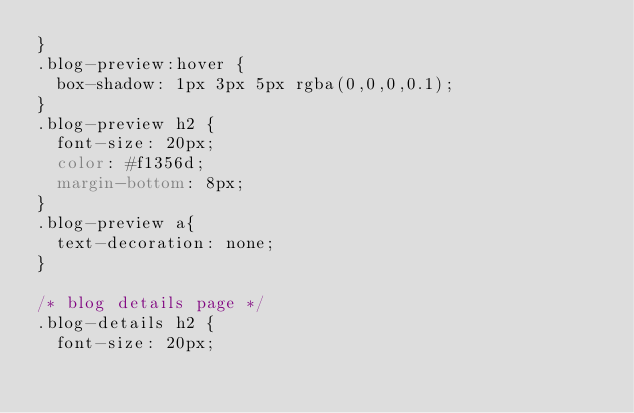<code> <loc_0><loc_0><loc_500><loc_500><_CSS_>}
.blog-preview:hover {
  box-shadow: 1px 3px 5px rgba(0,0,0,0.1);
}
.blog-preview h2 {
  font-size: 20px;
  color: #f1356d;
  margin-bottom: 8px;
}
.blog-preview a{
  text-decoration: none;
}

/* blog details page */
.blog-details h2 {
  font-size: 20px;</code> 